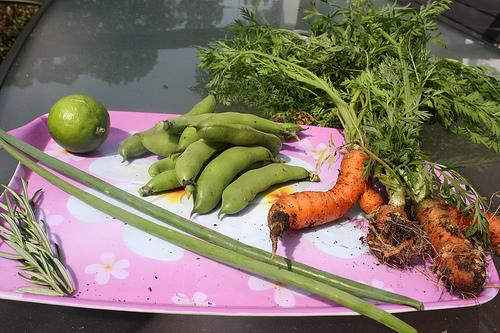Question: what colors are the plate?
Choices:
A. Red, green and blue.
B. Pink, yellow, and white.
C. Purple, black and grey.
D. Orange, brown and cream.
Answer with the letter. Answer: B Question: what type of fruit is on the plate?
Choices:
A. Lemon.
B. Orange.
C. Lime.
D. Strawberry.
Answer with the letter. Answer: C Question: how can you tell the carrots are fresh?
Choices:
A. Not mushy.
B. Still dirty.
C. Bright colors.
D. Smells good.
Answer with the letter. Answer: B Question: what is on the plate?
Choices:
A. Meat.
B. Fruit and vegetables.
C. Dessert.
D. Bread.
Answer with the letter. Answer: B Question: where are the carrots on the plate?
Choices:
A. On the right.
B. In the center.
C. On top.
D. On the bottom.
Answer with the letter. Answer: A 